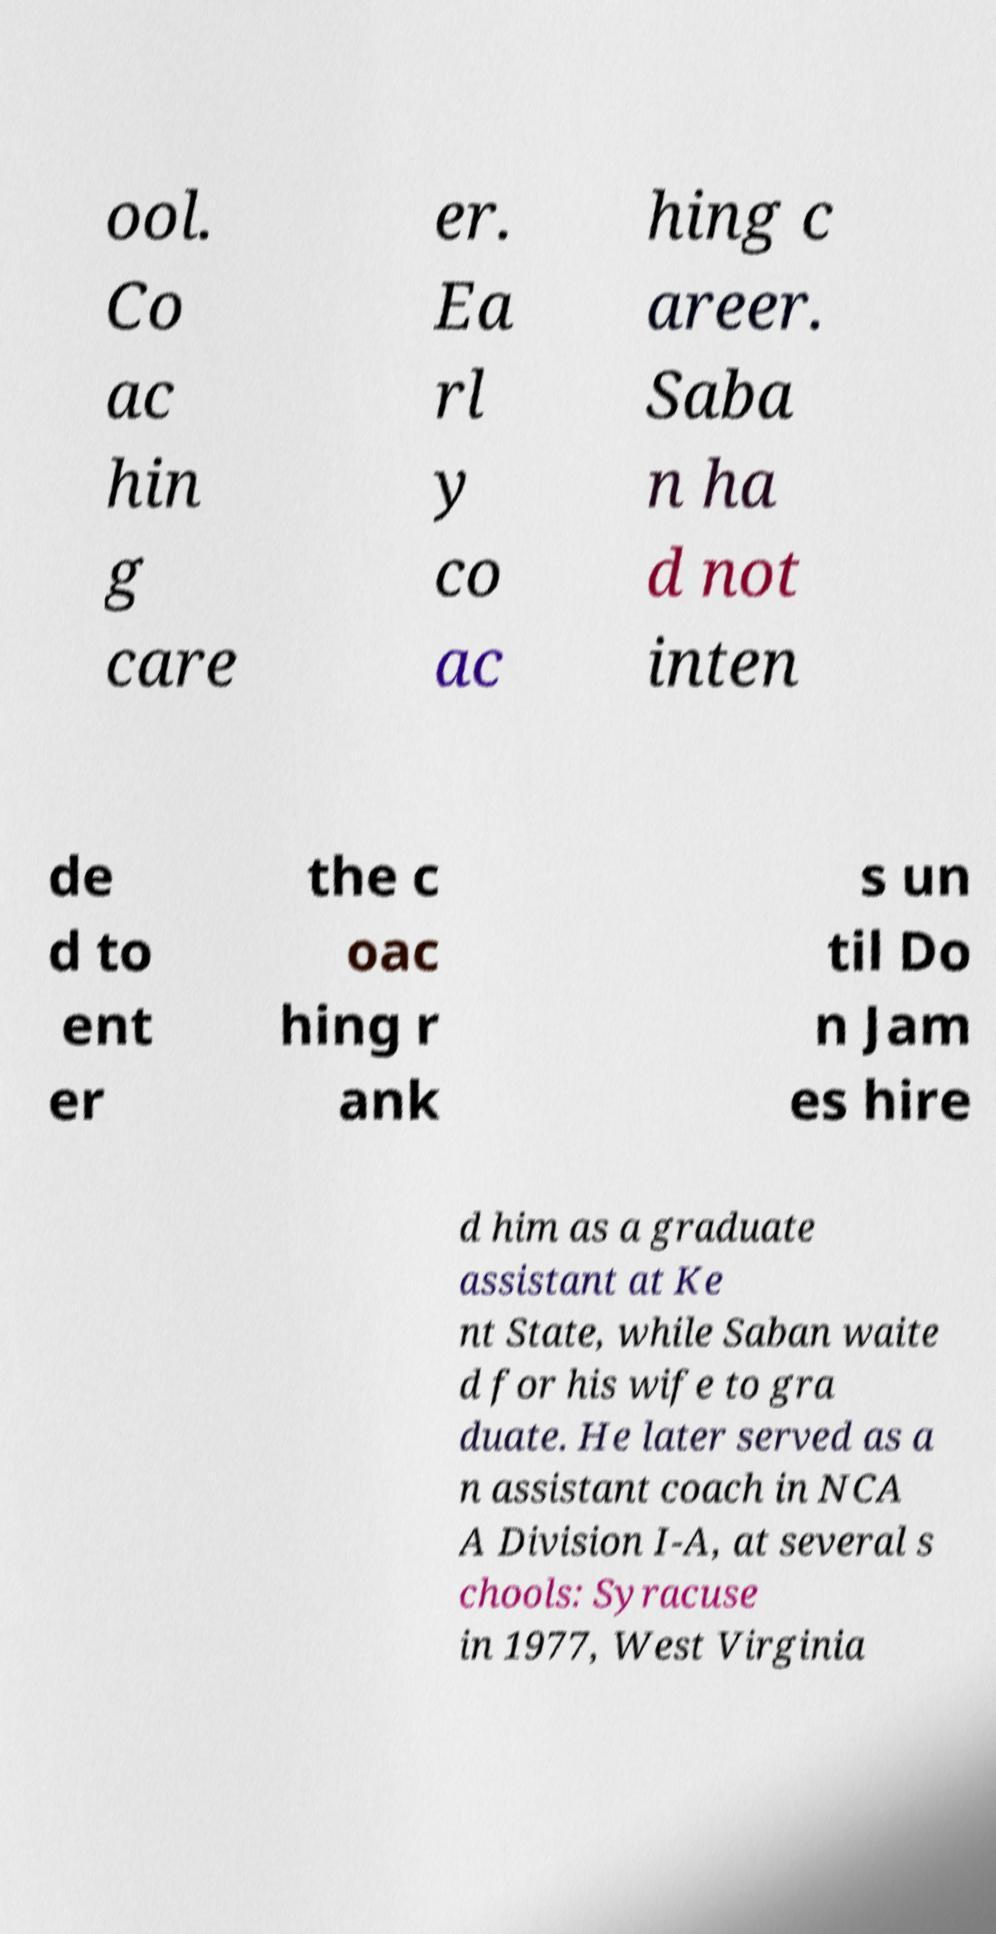Could you extract and type out the text from this image? ool. Co ac hin g care er. Ea rl y co ac hing c areer. Saba n ha d not inten de d to ent er the c oac hing r ank s un til Do n Jam es hire d him as a graduate assistant at Ke nt State, while Saban waite d for his wife to gra duate. He later served as a n assistant coach in NCA A Division I-A, at several s chools: Syracuse in 1977, West Virginia 